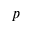<formula> <loc_0><loc_0><loc_500><loc_500>p</formula> 